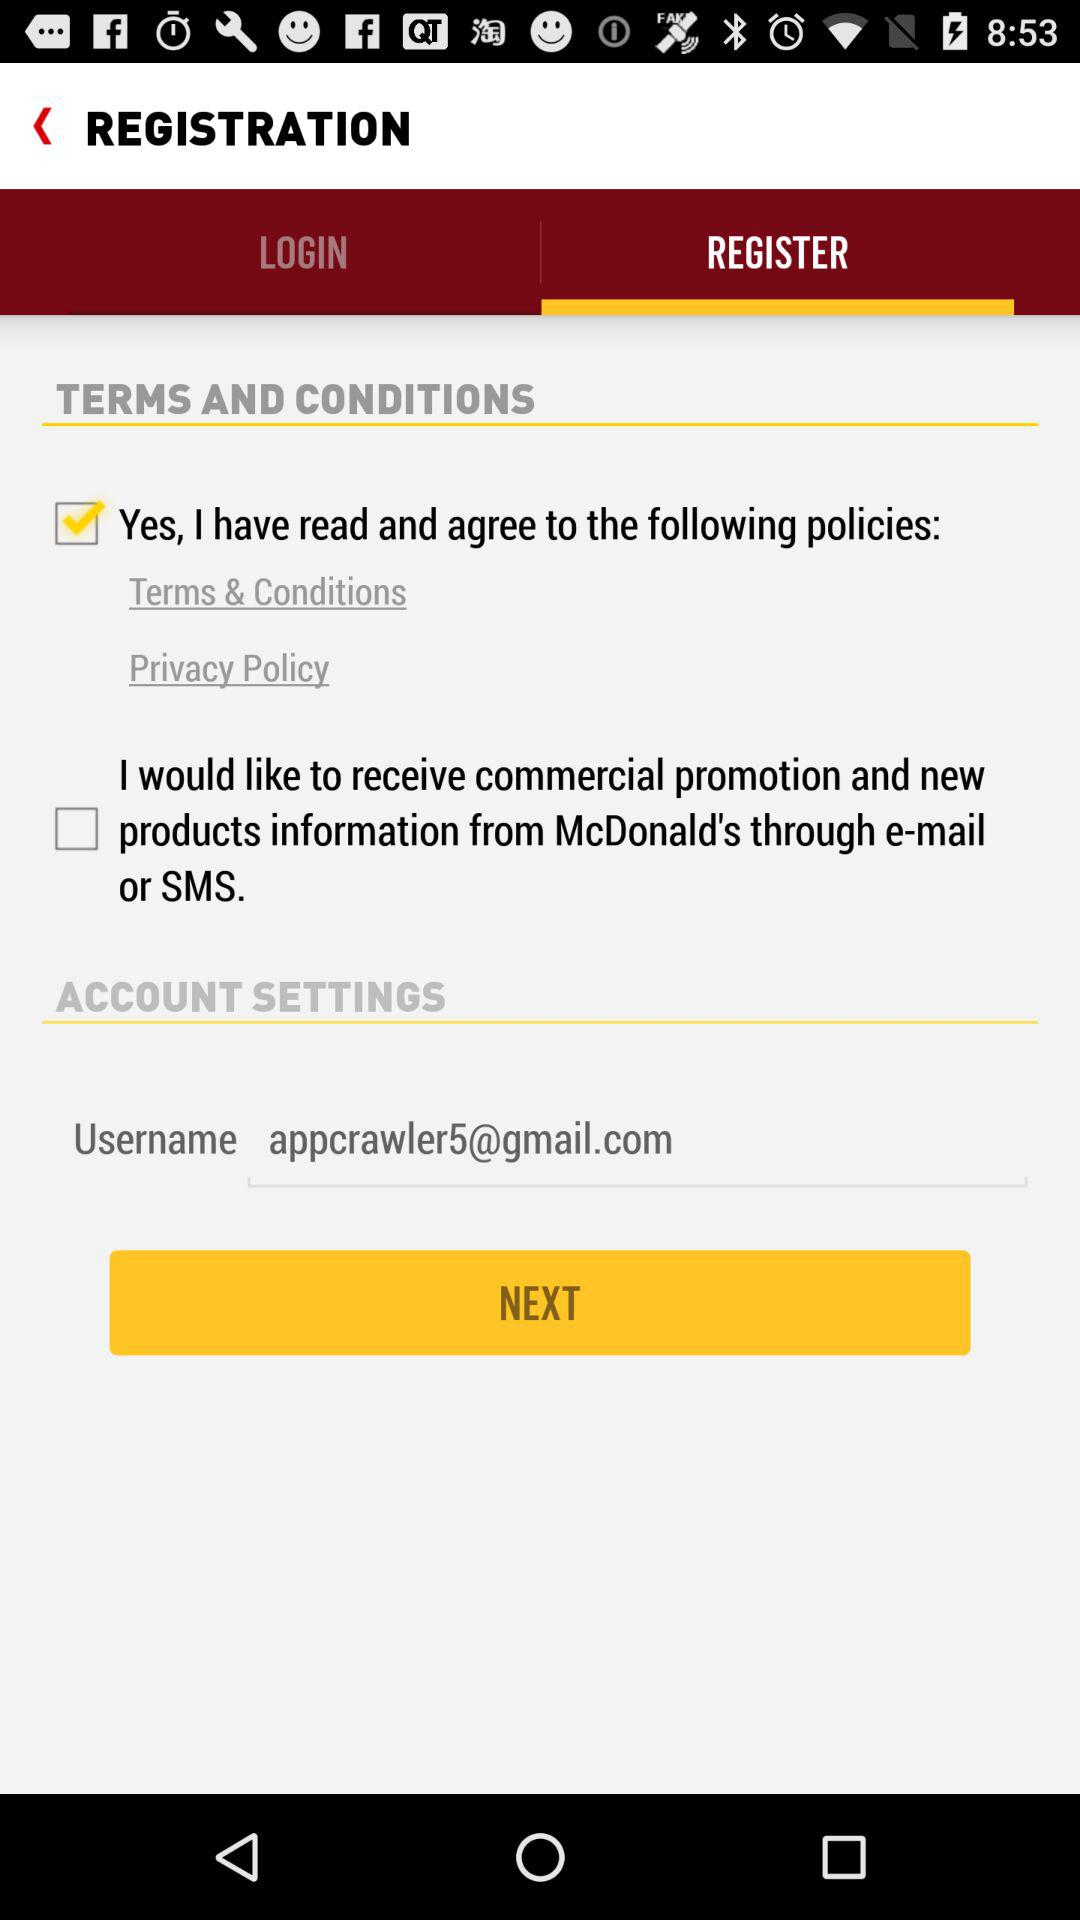Which terms and conditions have been checked? The checked term and condition is "Yes, I have read and agree to the following policies: Terms & Conditions and Privacy Policy". 